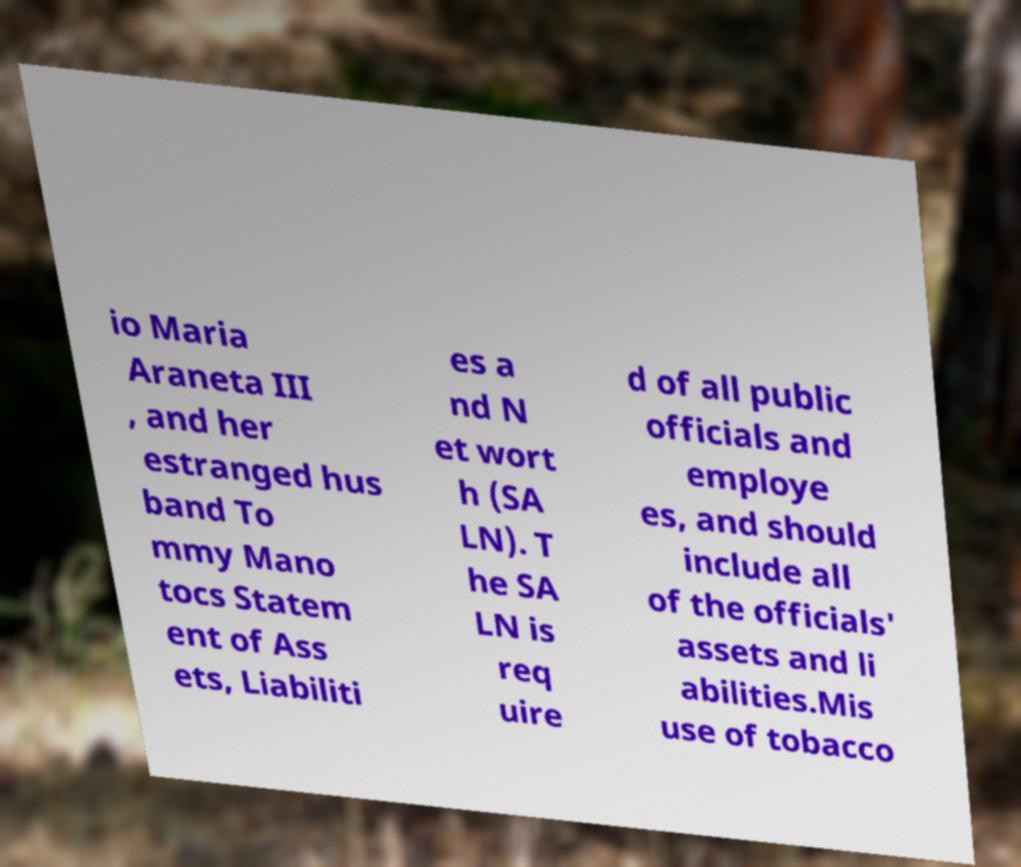There's text embedded in this image that I need extracted. Can you transcribe it verbatim? io Maria Araneta III , and her estranged hus band To mmy Mano tocs Statem ent of Ass ets, Liabiliti es a nd N et wort h (SA LN). T he SA LN is req uire d of all public officials and employe es, and should include all of the officials' assets and li abilities.Mis use of tobacco 